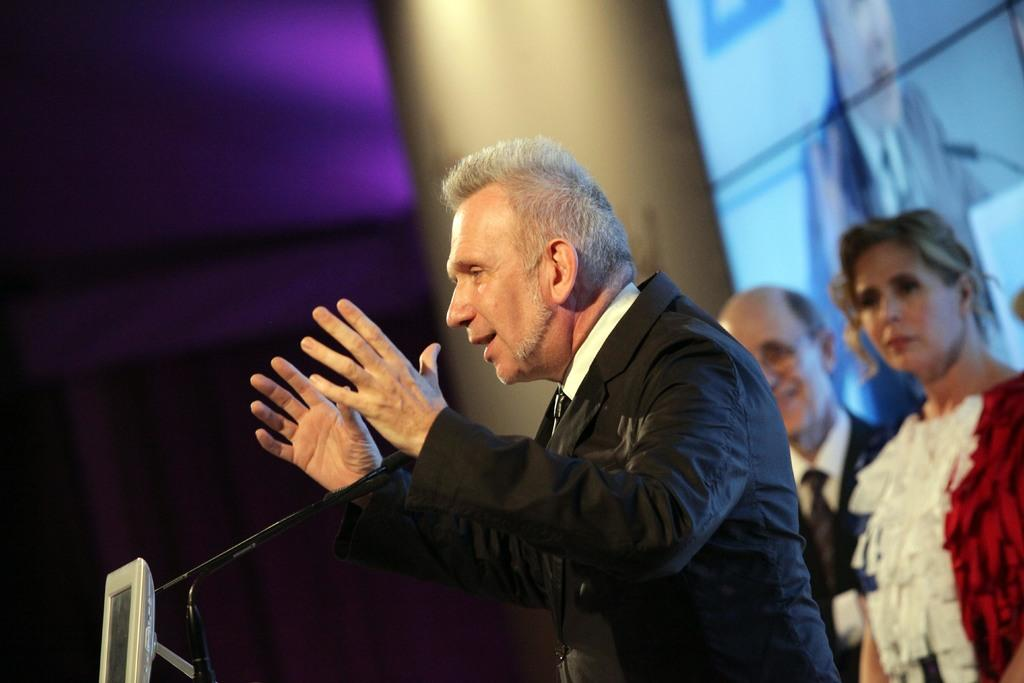What is the main subject of the image? There is a person standing in the center of the image. What object is in front of the person? There is a microphone in front of the person. What can be seen in the background of the image? There is a screen in the background of the image. Are there any other people visible in the image? Yes, there are two persons standing in the background of the image. How many letters are visible on the screen in the image? There is no information about letters on the screen in the provided facts, so we cannot determine the number of letters visible. 